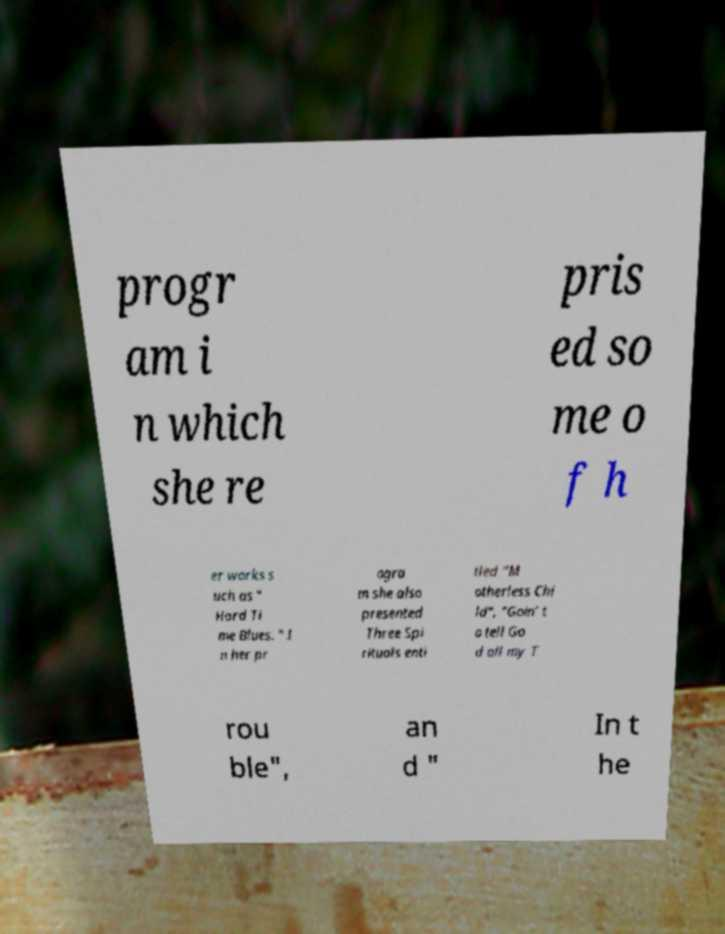What messages or text are displayed in this image? I need them in a readable, typed format. progr am i n which she re pris ed so me o f h er works s uch as " Hard Ti me Blues. " I n her pr ogra m she also presented Three Spi rituals enti tled "M otherless Chi ld", "Goin’ t o tell Go d all my T rou ble", an d " In t he 